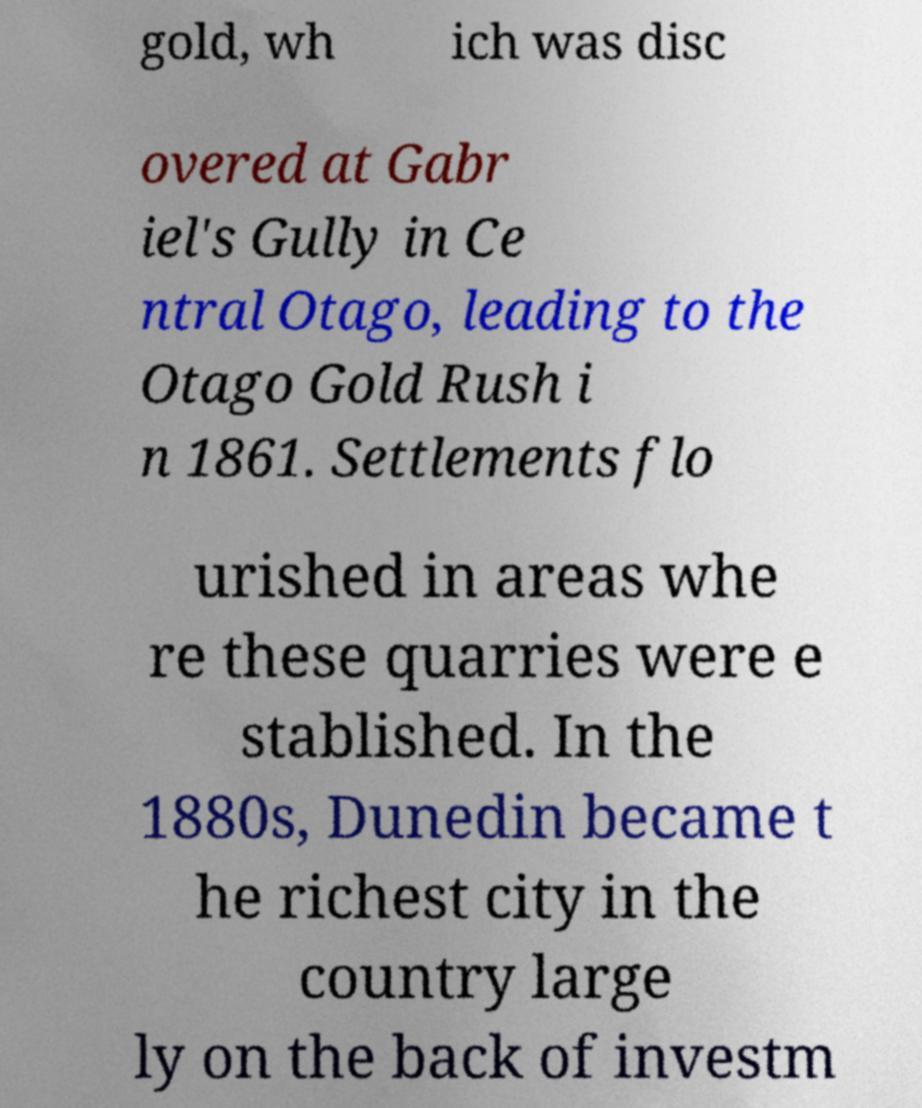I need the written content from this picture converted into text. Can you do that? gold, wh ich was disc overed at Gabr iel's Gully in Ce ntral Otago, leading to the Otago Gold Rush i n 1861. Settlements flo urished in areas whe re these quarries were e stablished. In the 1880s, Dunedin became t he richest city in the country large ly on the back of investm 